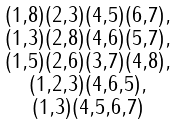Convert formula to latex. <formula><loc_0><loc_0><loc_500><loc_500>\begin{smallmatrix} ( 1 , 8 ) ( 2 , 3 ) ( 4 , 5 ) ( 6 , 7 ) , \\ ( 1 , 3 ) ( 2 , 8 ) ( 4 , 6 ) ( 5 , 7 ) , \\ ( 1 , 5 ) ( 2 , 6 ) ( 3 , 7 ) ( 4 , 8 ) , \\ ( 1 , 2 , 3 ) ( 4 , 6 , 5 ) , \\ ( 1 , 3 ) ( 4 , 5 , 6 , 7 ) \end{smallmatrix}</formula> 